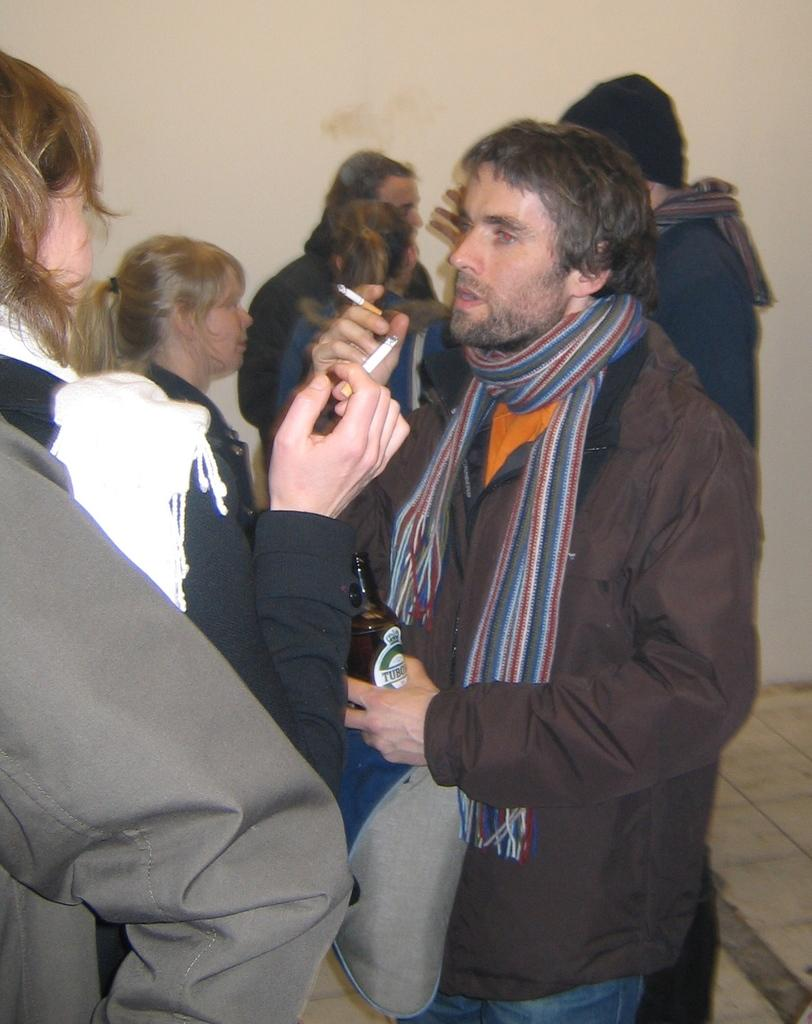What are the two people holding in the image? The two people are holding cigarettes in the image. What else is one of the people holding? One person is holding a bottle in the image. Can you describe the presence of other people in the image? There are other people present in the image. What type of club is being played in the image? There is no club or any indication of a club being played in the image. 